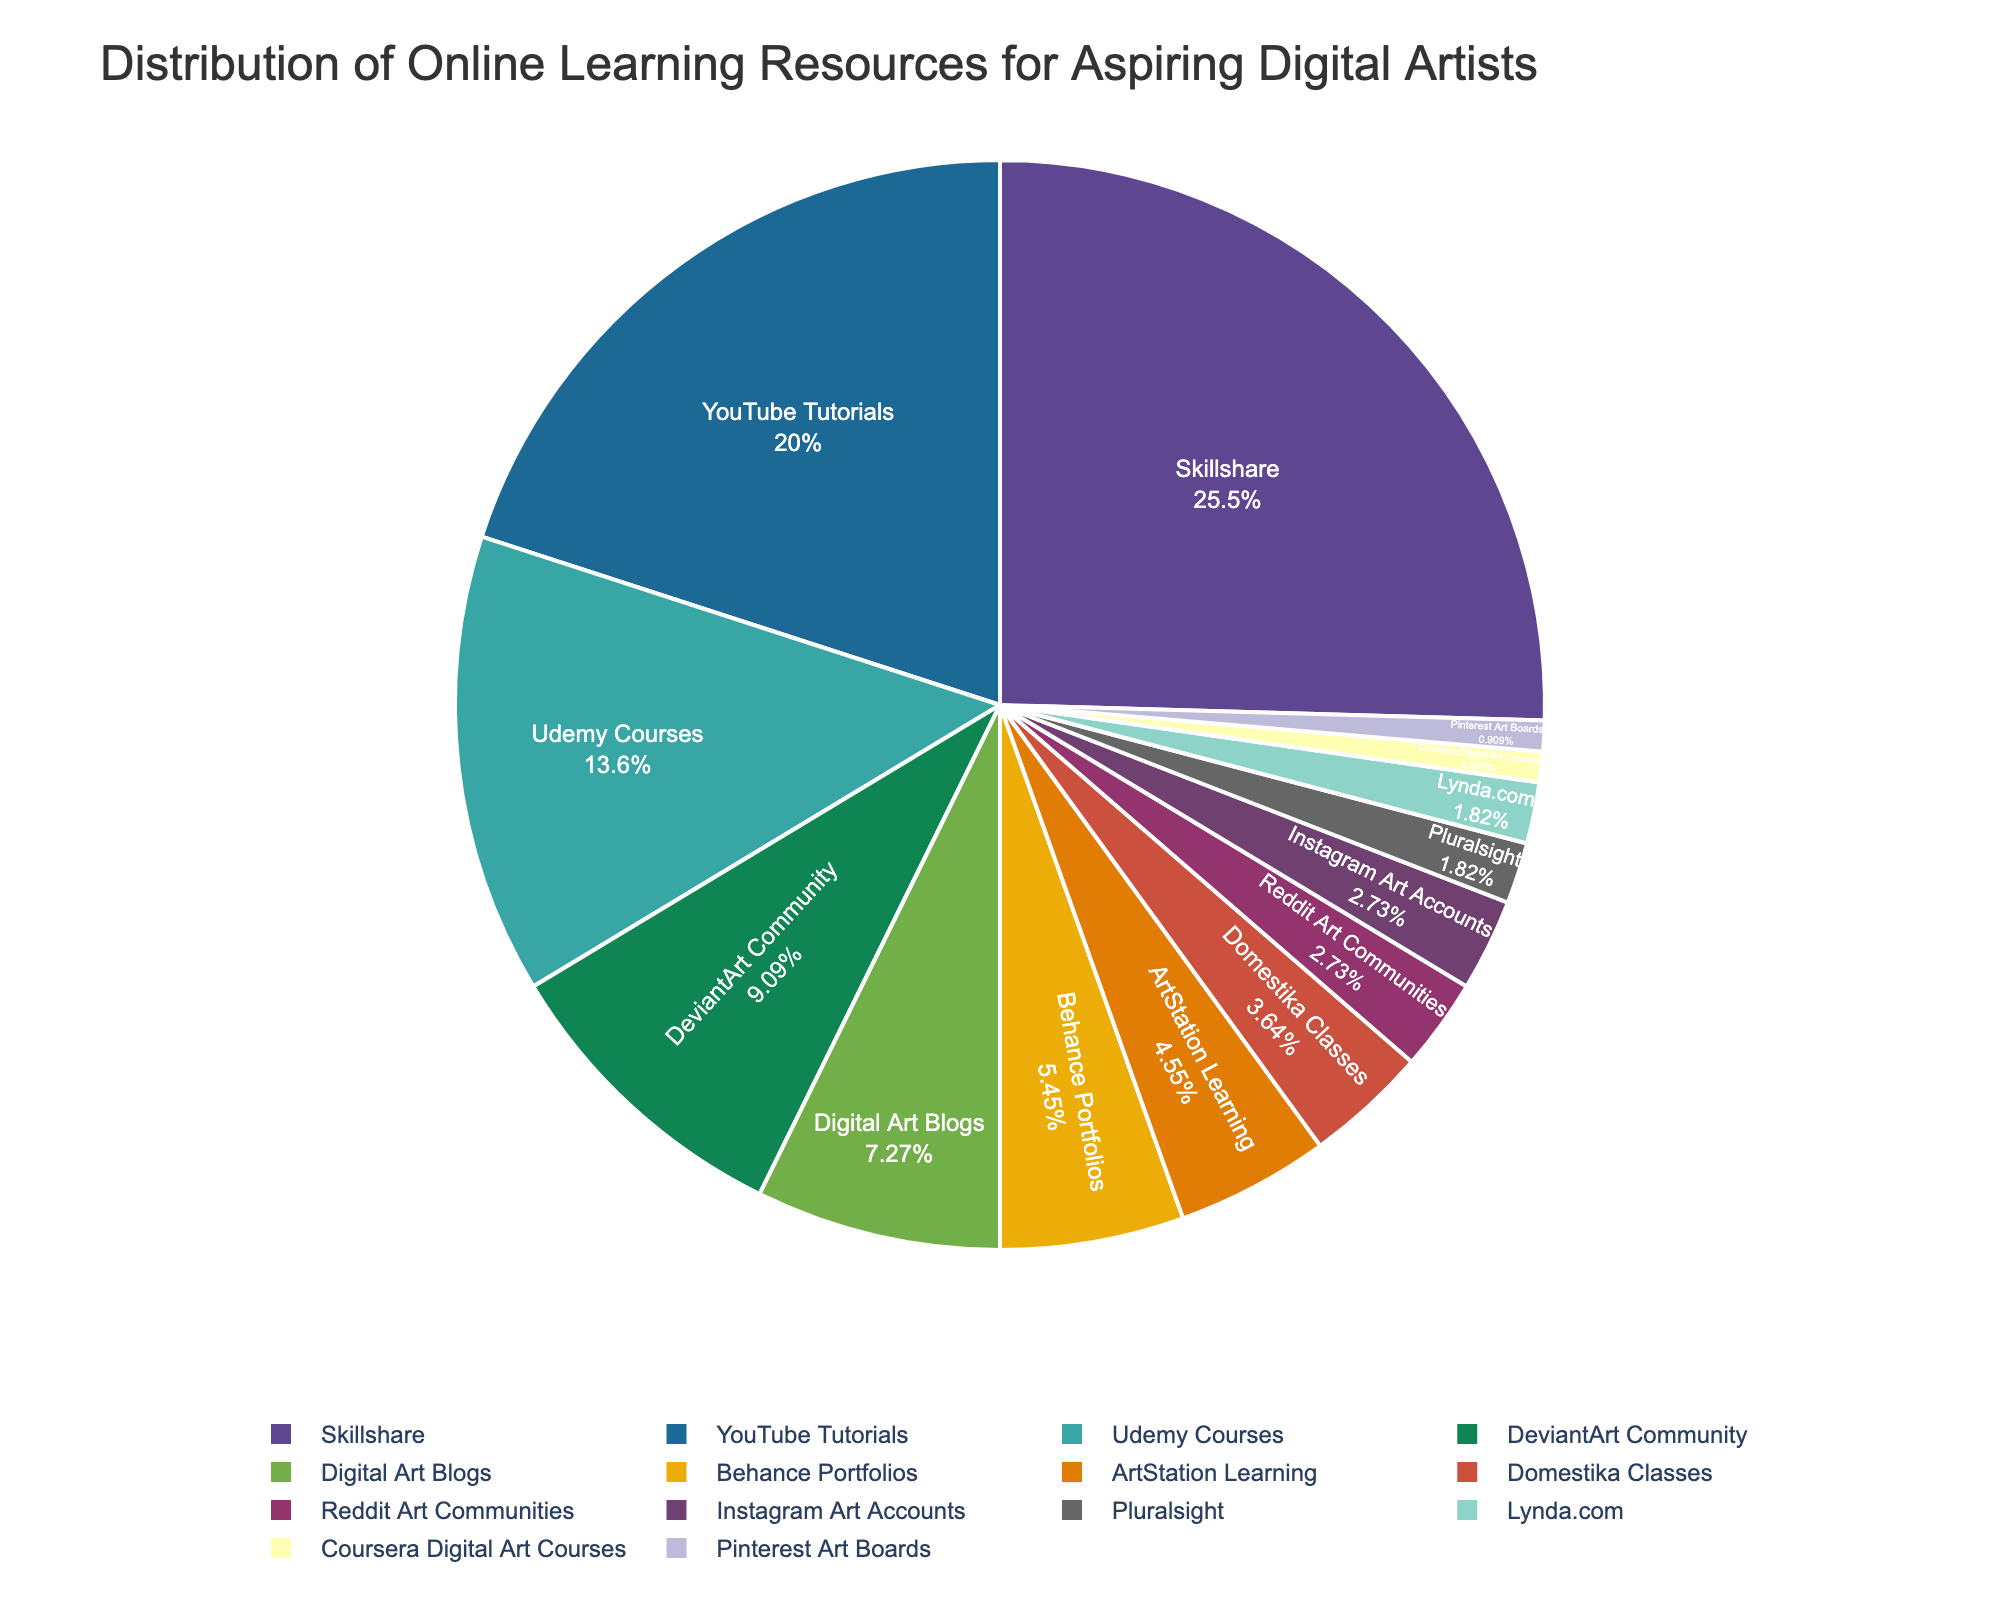what percentage of aspiring digital artists use YouTube Tutorials compared to Skilshare? YouTube Tutorials account for 22% and Skillshare accounts for 28%. As 28% is greater than 22%, Skillshare is used more by aspiring digital artists.
Answer: Skillshare what is the total percentage of aspiring digital artists preferring community-based resources? Adding the percentages of community-based resources: DeviantArt Community (10%), Reddit Art Communities (3%), and Instagram Art Accounts (3%), gives 10% + 3% + 3% = 16%.
Answer: 16% which resource has the smallest representation? Coursera Digital Art Courses and Pinterest Art Boards each account for 1%, indicating they have the smallest representation.
Answer: Coursera Digital Art Courses, Pinterest Art Boards how much more usage does Udemy Courses have compared to ArtStation Learning? Udemy Courses account for 15% while ArtStation Learning accounts for 5%. The difference is 15% - 5% = 10%.
Answer: 10% among YouTube Tutorials, Digital Art Blogs, and Instagram Art Accounts, which has the highest percentage? Among YouTube Tutorials (22%), Digital Art Blogs (8%), and Instagram Art Accounts (3%), YouTube Tutorials has the highest percentage.
Answer: YouTube Tutorials what percentage of aspiring digital artists use Behance Portfolios or Domestika Classes? Adding the percentages of Behance Portfolios (6%) and Domestika Classes (4%) gives 6% + 4% = 10%.
Answer: 10% how does the usage of traditional educational platforms (e.g., Pluralsight, Lynda.com, Coursera) compare overall to Skillshare? Summing the percentages of Pluralsight (2%), Lynda.com (2%), and Coursera Digital Art Courses (1%) gives a total of 2% + 2% + 1% = 5%, which is less compared to Skillshare's 28%.
Answer: Less what proportion of the total usage do the bottom four resources account for? The bottom four resources are Coursera Digital Art Courses (1%), Pinterest Art Boards (1%), Pluralsight (2%), and Lynda.com (2%). Adding their percentages gives 1% + 1% + 2% + 2% = 6%.
Answer: 6% 